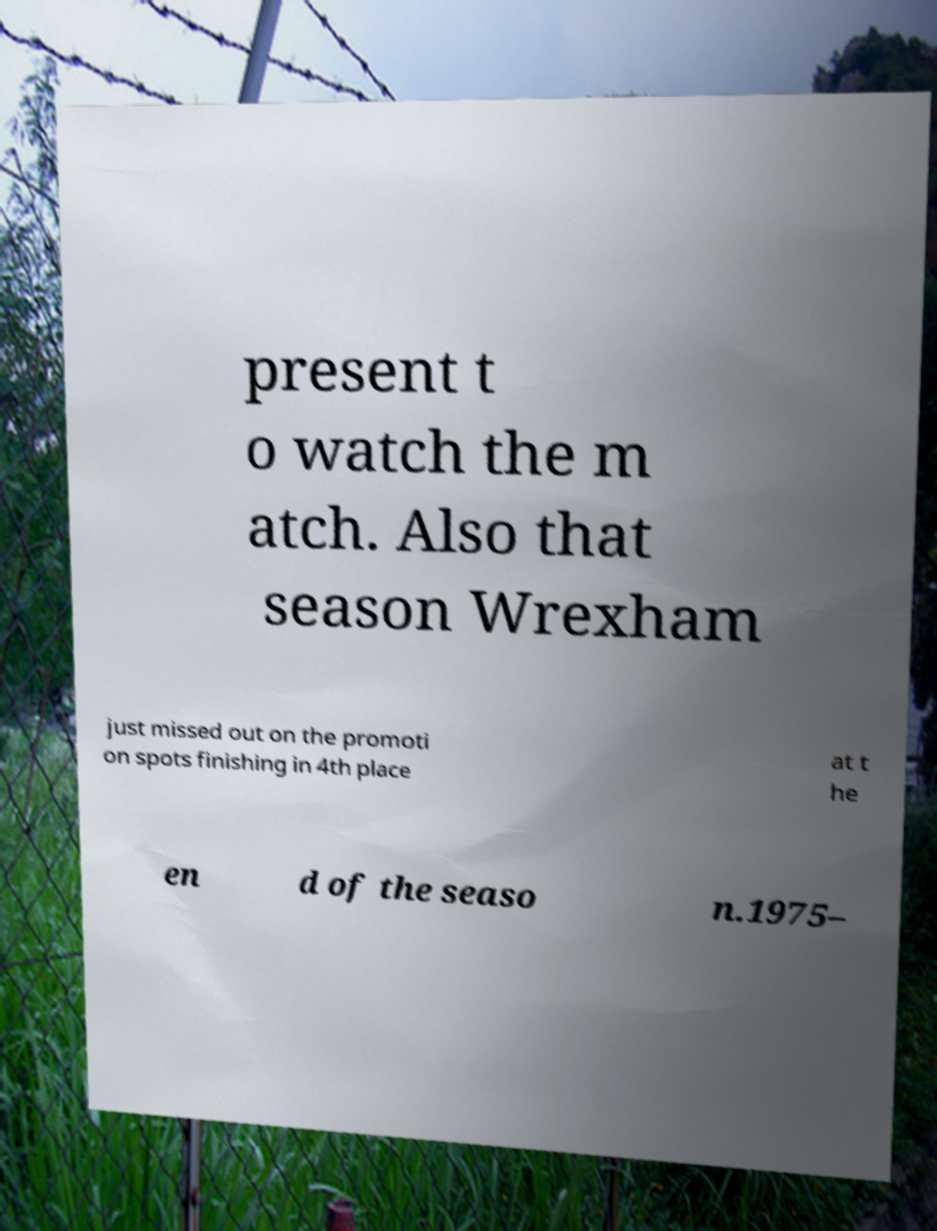Could you assist in decoding the text presented in this image and type it out clearly? present t o watch the m atch. Also that season Wrexham just missed out on the promoti on spots finishing in 4th place at t he en d of the seaso n.1975– 